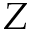<formula> <loc_0><loc_0><loc_500><loc_500>Z</formula> 